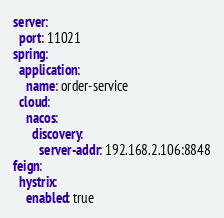Convert code to text. <code><loc_0><loc_0><loc_500><loc_500><_YAML_>server:
  port: 11021
spring:
  application:
    name: order-service
  cloud:
    nacos:
      discovery:
        server-addr: 192.168.2.106:8848
feign:
  hystrix:
    enabled: true</code> 